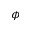<formula> <loc_0><loc_0><loc_500><loc_500>\phi</formula> 